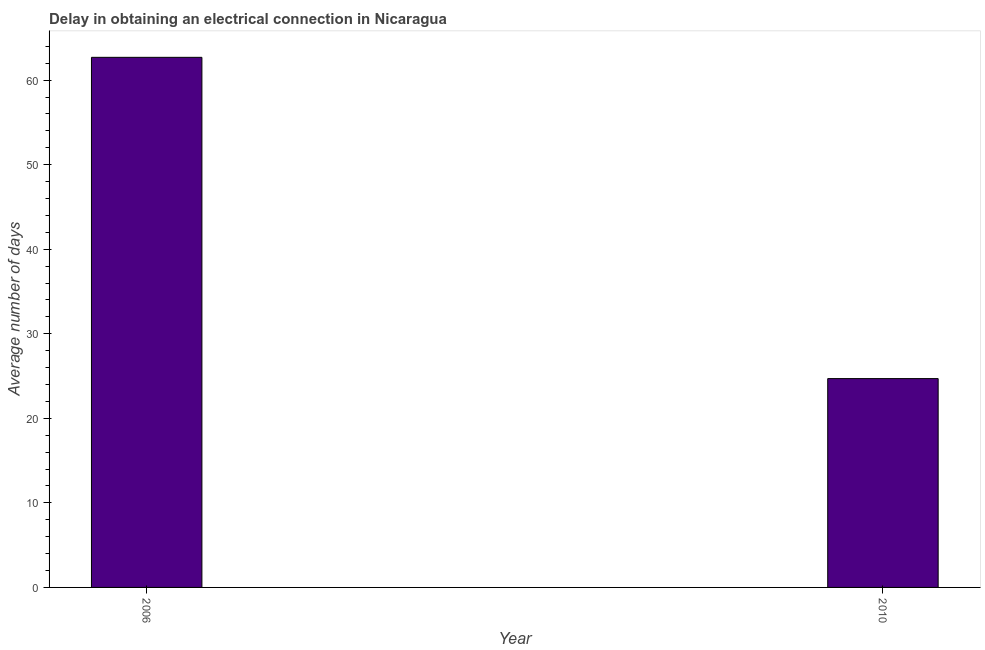Does the graph contain grids?
Offer a terse response. No. What is the title of the graph?
Your answer should be compact. Delay in obtaining an electrical connection in Nicaragua. What is the label or title of the Y-axis?
Offer a very short reply. Average number of days. What is the dalay in electrical connection in 2010?
Keep it short and to the point. 24.7. Across all years, what is the maximum dalay in electrical connection?
Provide a succinct answer. 62.7. Across all years, what is the minimum dalay in electrical connection?
Your answer should be very brief. 24.7. What is the sum of the dalay in electrical connection?
Your response must be concise. 87.4. What is the difference between the dalay in electrical connection in 2006 and 2010?
Your answer should be compact. 38. What is the average dalay in electrical connection per year?
Make the answer very short. 43.7. What is the median dalay in electrical connection?
Offer a terse response. 43.7. In how many years, is the dalay in electrical connection greater than 58 days?
Your answer should be very brief. 1. Do a majority of the years between 2006 and 2010 (inclusive) have dalay in electrical connection greater than 2 days?
Your response must be concise. Yes. What is the ratio of the dalay in electrical connection in 2006 to that in 2010?
Provide a succinct answer. 2.54. In how many years, is the dalay in electrical connection greater than the average dalay in electrical connection taken over all years?
Offer a very short reply. 1. How many bars are there?
Provide a short and direct response. 2. Are all the bars in the graph horizontal?
Offer a very short reply. No. Are the values on the major ticks of Y-axis written in scientific E-notation?
Keep it short and to the point. No. What is the Average number of days of 2006?
Keep it short and to the point. 62.7. What is the Average number of days of 2010?
Keep it short and to the point. 24.7. What is the difference between the Average number of days in 2006 and 2010?
Your answer should be very brief. 38. What is the ratio of the Average number of days in 2006 to that in 2010?
Offer a terse response. 2.54. 